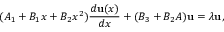<formula> <loc_0><loc_0><loc_500><loc_500>( A _ { 1 } + B _ { 1 } x + B _ { 2 } x ^ { 2 } ) { \frac { d { u } ( x ) } { d x } } + ( B _ { 3 } + B _ { 2 } A ) { u } = \lambda { u } ,</formula> 